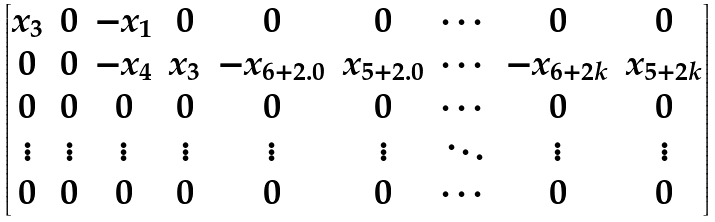<formula> <loc_0><loc_0><loc_500><loc_500>\begin{bmatrix} x _ { 3 } & 0 & - x _ { 1 } & 0 & 0 & 0 & \cdots & 0 & 0 \\ 0 & 0 & - x _ { 4 } & x _ { 3 } & - x _ { 6 + 2 . 0 } & x _ { 5 + 2 . 0 } & \cdots & - x _ { 6 + 2 k } & x _ { 5 + 2 k } \\ 0 & 0 & 0 & 0 & 0 & 0 & \cdots & 0 & 0 \\ \vdots & \vdots & \vdots & \vdots & \vdots & \vdots & \ddots & \vdots & \vdots \\ 0 & 0 & 0 & 0 & 0 & 0 & \cdots & 0 & 0 \end{bmatrix}</formula> 